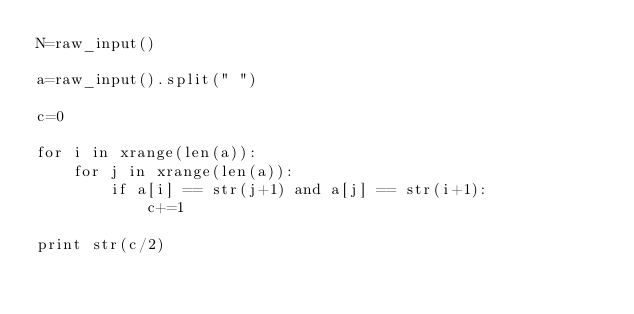Convert code to text. <code><loc_0><loc_0><loc_500><loc_500><_Python_>N=raw_input()

a=raw_input().split(" ")

c=0

for i in xrange(len(a)):
    for j in xrange(len(a)):
        if a[i] == str(j+1) and a[j] == str(i+1):
            c+=1

print str(c/2)</code> 